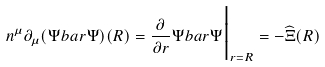Convert formula to latex. <formula><loc_0><loc_0><loc_500><loc_500>n ^ { \mu } \partial _ { \mu } ( \Psi b a r \Psi ) ( R ) = \frac { \partial } { \partial r } \Psi b a r \Psi \Big | _ { r = R } = - \widehat { \Xi } ( R )</formula> 